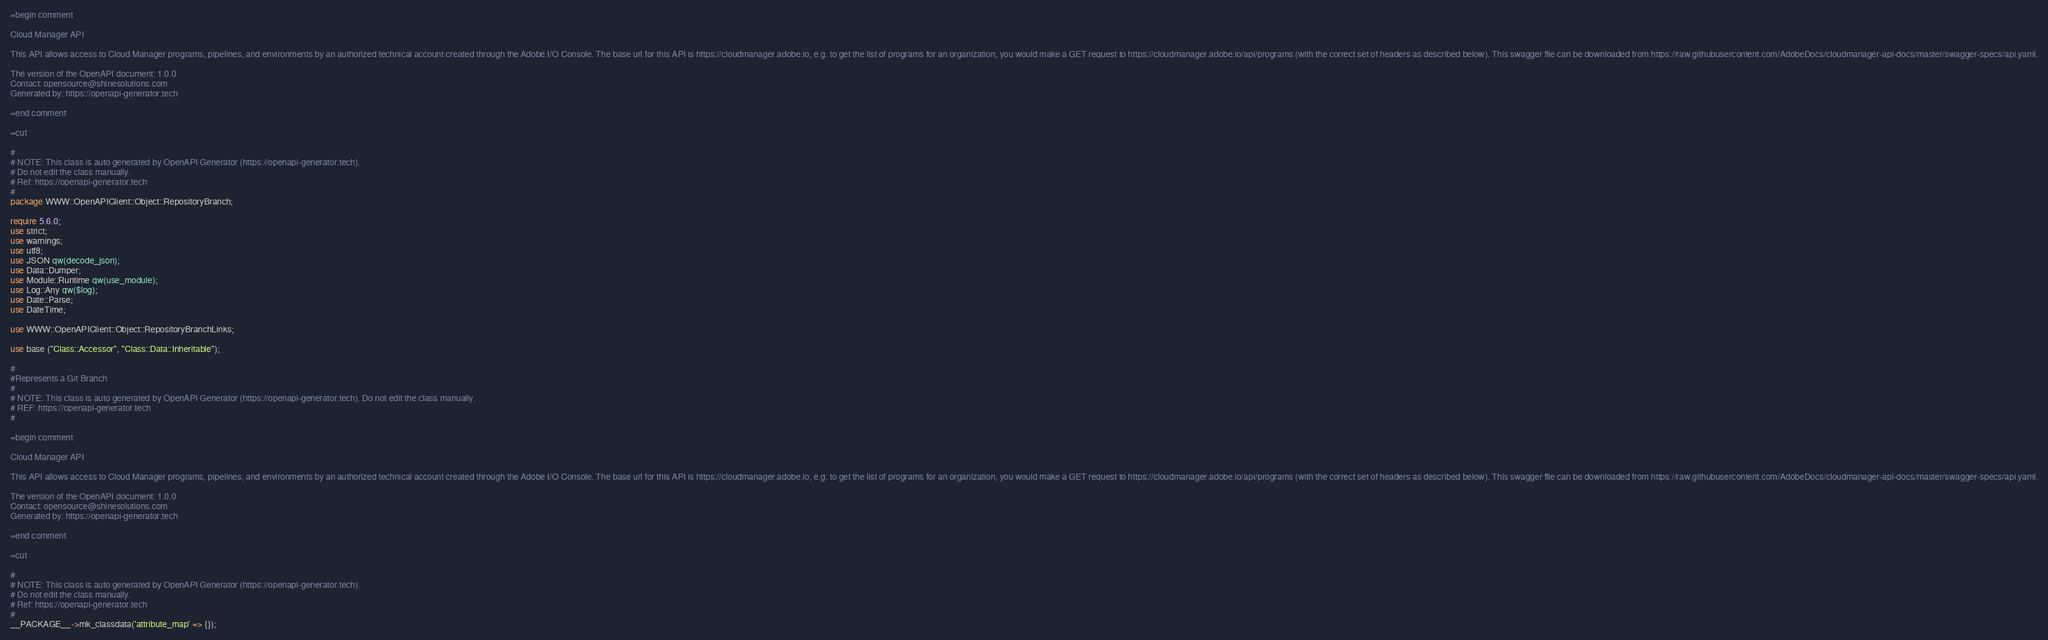Convert code to text. <code><loc_0><loc_0><loc_500><loc_500><_Perl_>=begin comment

Cloud Manager API

This API allows access to Cloud Manager programs, pipelines, and environments by an authorized technical account created through the Adobe I/O Console. The base url for this API is https://cloudmanager.adobe.io, e.g. to get the list of programs for an organization, you would make a GET request to https://cloudmanager.adobe.io/api/programs (with the correct set of headers as described below). This swagger file can be downloaded from https://raw.githubusercontent.com/AdobeDocs/cloudmanager-api-docs/master/swagger-specs/api.yaml.

The version of the OpenAPI document: 1.0.0
Contact: opensource@shinesolutions.com
Generated by: https://openapi-generator.tech

=end comment

=cut

#
# NOTE: This class is auto generated by OpenAPI Generator (https://openapi-generator.tech).
# Do not edit the class manually.
# Ref: https://openapi-generator.tech
#
package WWW::OpenAPIClient::Object::RepositoryBranch;

require 5.6.0;
use strict;
use warnings;
use utf8;
use JSON qw(decode_json);
use Data::Dumper;
use Module::Runtime qw(use_module);
use Log::Any qw($log);
use Date::Parse;
use DateTime;

use WWW::OpenAPIClient::Object::RepositoryBranchLinks;

use base ("Class::Accessor", "Class::Data::Inheritable");

#
#Represents a Git Branch
#
# NOTE: This class is auto generated by OpenAPI Generator (https://openapi-generator.tech). Do not edit the class manually.
# REF: https://openapi-generator.tech
#

=begin comment

Cloud Manager API

This API allows access to Cloud Manager programs, pipelines, and environments by an authorized technical account created through the Adobe I/O Console. The base url for this API is https://cloudmanager.adobe.io, e.g. to get the list of programs for an organization, you would make a GET request to https://cloudmanager.adobe.io/api/programs (with the correct set of headers as described below). This swagger file can be downloaded from https://raw.githubusercontent.com/AdobeDocs/cloudmanager-api-docs/master/swagger-specs/api.yaml.

The version of the OpenAPI document: 1.0.0
Contact: opensource@shinesolutions.com
Generated by: https://openapi-generator.tech

=end comment

=cut

#
# NOTE: This class is auto generated by OpenAPI Generator (https://openapi-generator.tech).
# Do not edit the class manually.
# Ref: https://openapi-generator.tech
#
__PACKAGE__->mk_classdata('attribute_map' => {});</code> 